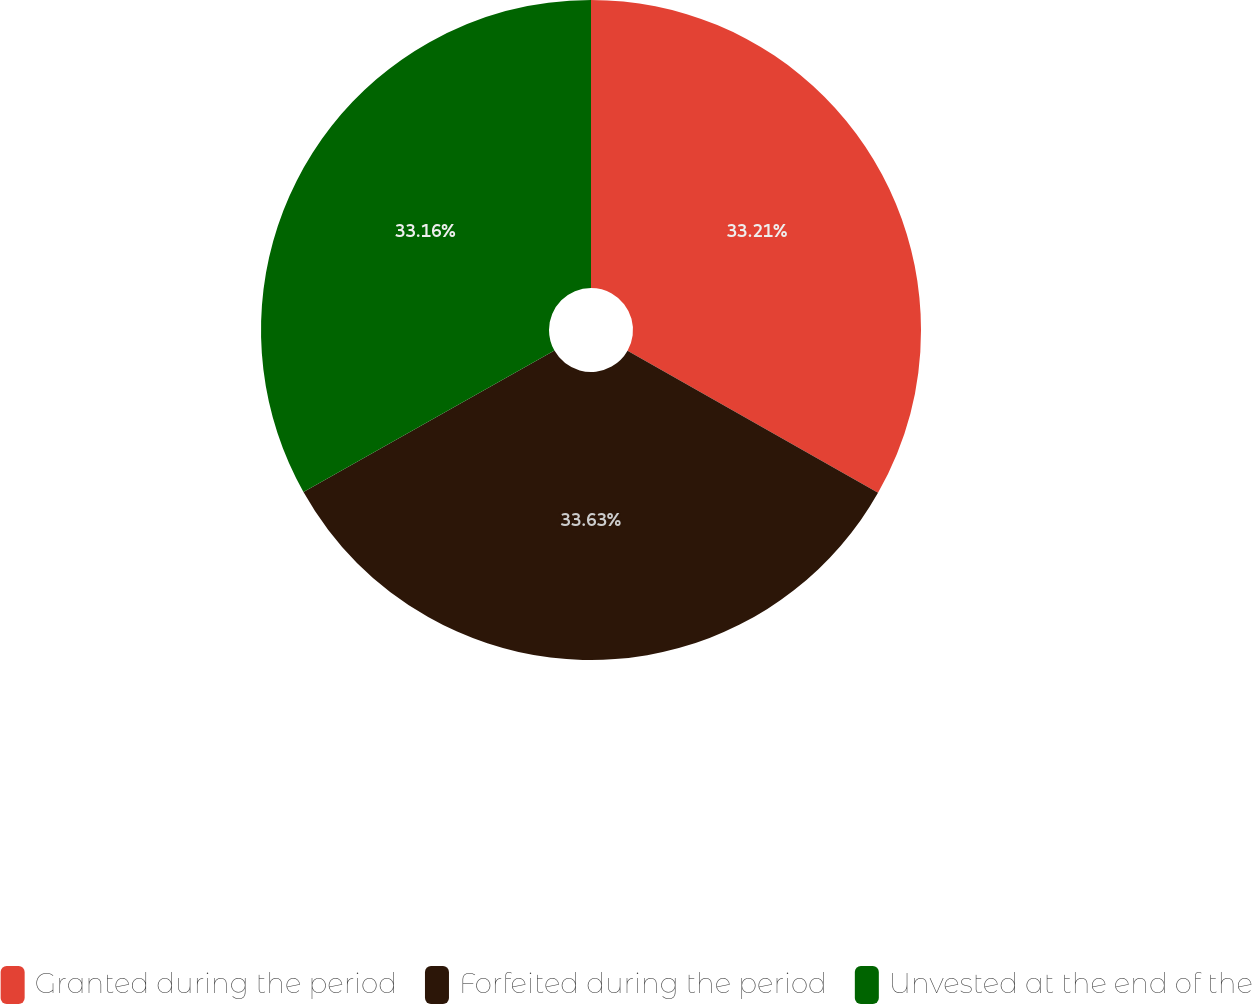Convert chart to OTSL. <chart><loc_0><loc_0><loc_500><loc_500><pie_chart><fcel>Granted during the period<fcel>Forfeited during the period<fcel>Unvested at the end of the<nl><fcel>33.21%<fcel>33.62%<fcel>33.16%<nl></chart> 